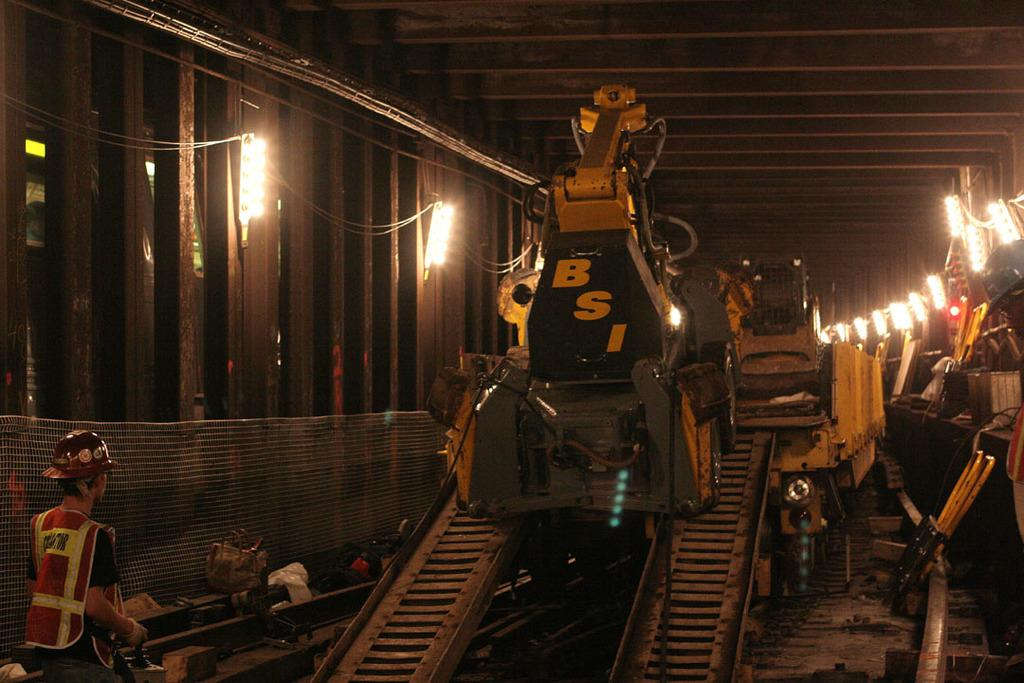What color are the machines in the middle of the image? The machines in the middle of the image are yellow. Who is present on the left side of the image? A man is present on the left side of the image. What is the man wearing on his head? The man is wearing a helmet. What can be seen on the wall in the image? There are lights on the wall in the image. What type of behavior is the man exhibiting in the image? The provided facts do not give any information about the man's behavior, so it cannot be determined from the image. How many clocks are visible in the image? There is no mention of clocks in the provided facts, so it cannot be determined from the image. 